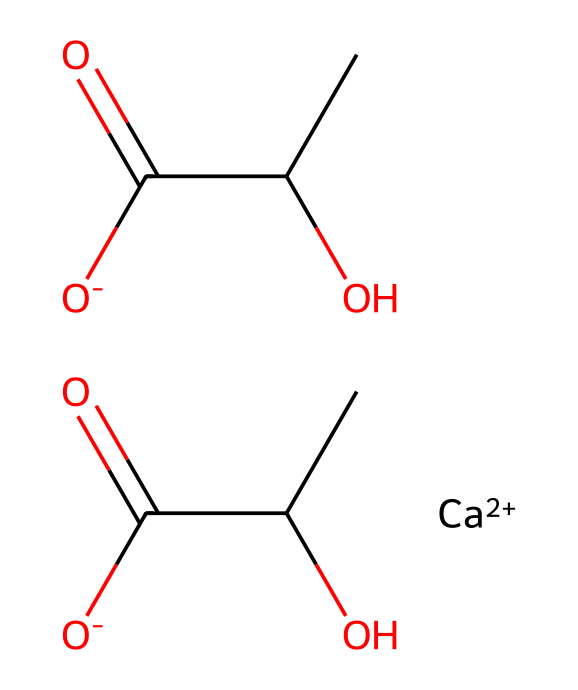How many carbon atoms are present in calcium lactate? By analyzing the SMILES representation, we can identify that there are four carbon atoms represented by "C" and the carbonyl groups "C(=O)" are not separate carbons but part of the carbonate structure. Thus, total counted is four.
Answer: four What type of ion is present in calcium lactate? The SMILES representation indicates the presence of "[Ca++]", which signifies that calcium is a divalent cation. Therefore, the type of ion is a calcium ion.
Answer: calcium ion How many hydroxyl (–OH) groups are there in calcium lactate? The structure shows that there are two "C(O)" which corresponds to two hydroxyl groups linked to carbon, allowing us to conclude that there are two hydroxyl (–OH) groups.
Answer: two What is the charge of the lactate anion in calcium lactate? The presence of "[O-]" indicates that each lactate is negatively charged. Therefore, the lactate anion has a negative charge.
Answer: negative What role do electrolytes like calcium lactate play in performance-enhancing gels? Electrolytes, including calcium lactate, help maintain fluid balance and provide necessary ions. This is crucial for athletic performance, especially in hydration and muscle function.
Answer: fluid balance How many total oxygen atoms are in calcium lactate? Upon examining the structure, each lactate ion contributes three oxygen atoms and since there are two lactate structures present, the total number of oxygen atoms is six.
Answer: six 